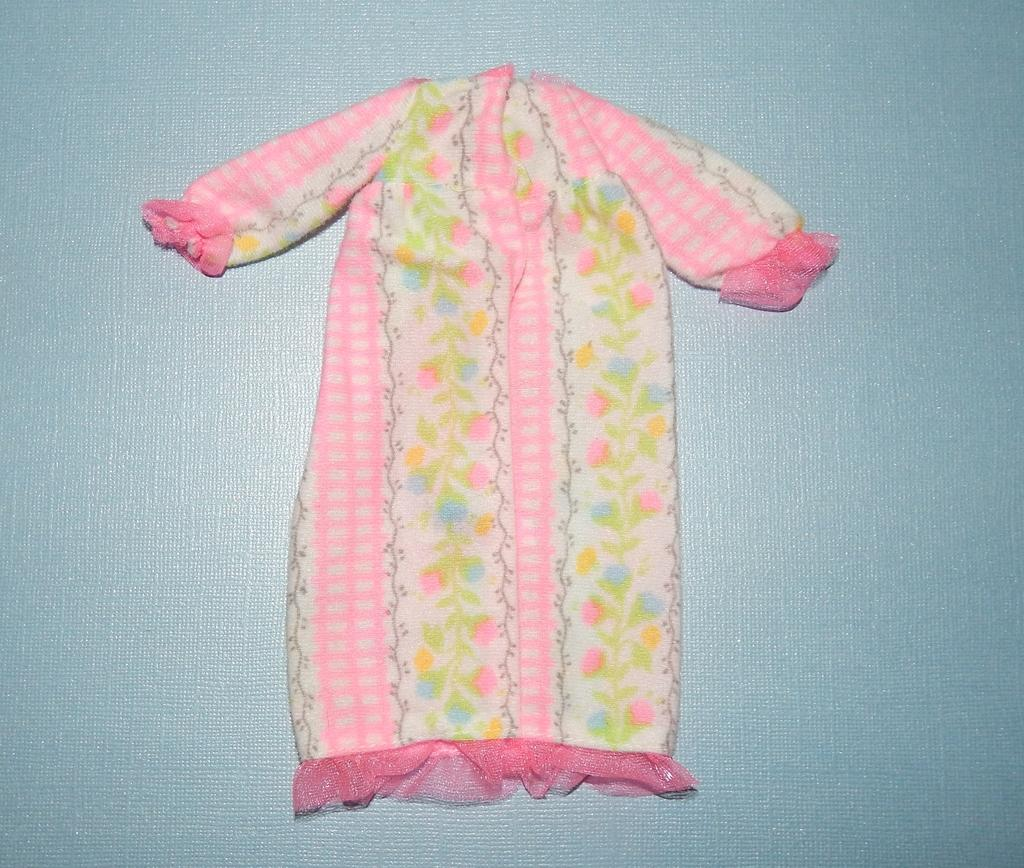What is present on a surface in the image? There is a cloth in the image. Can you describe the position or state of the cloth in the image? The cloth is on a surface. How does the bee interact with the cushion in the image? There is no cushion or bee present in the image; it only features a cloth on a surface. 